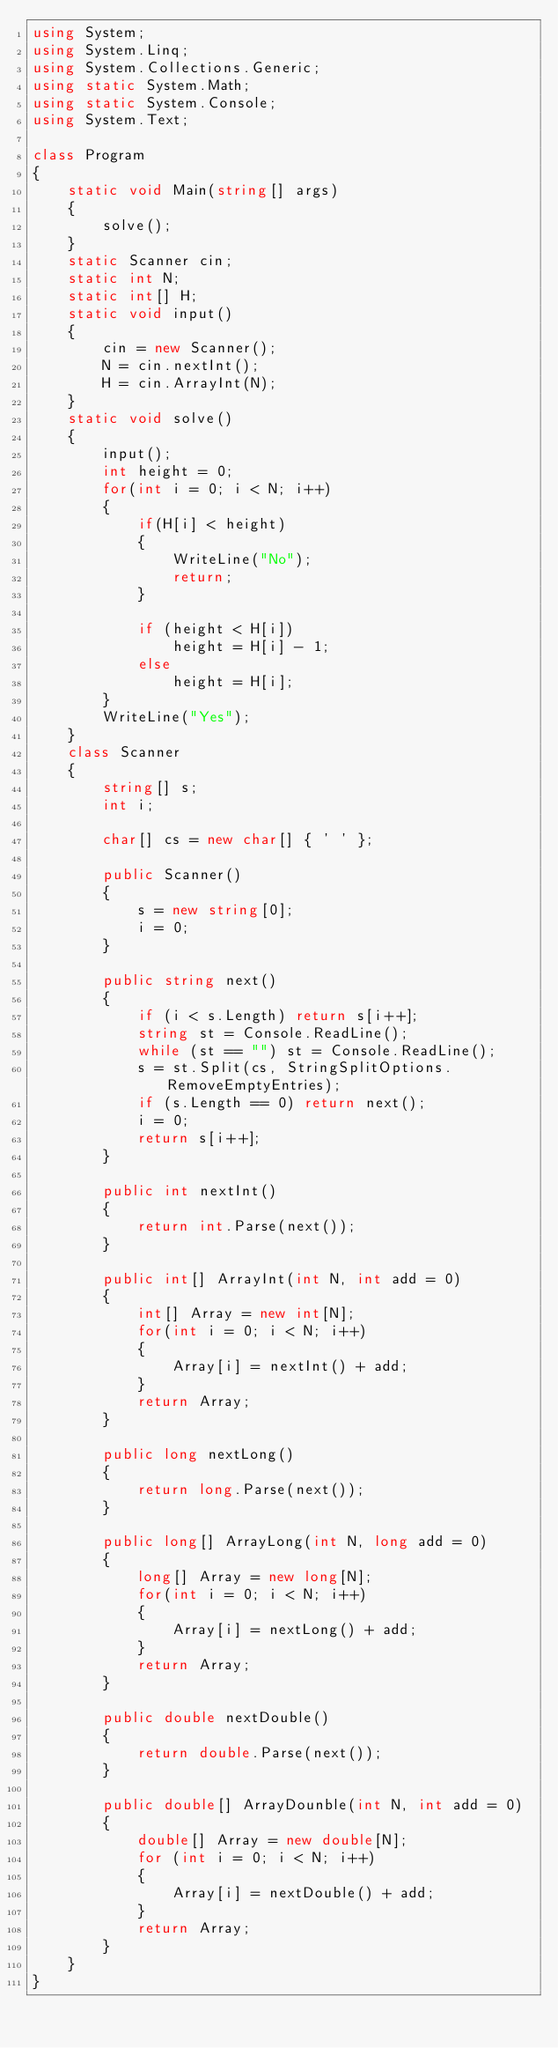<code> <loc_0><loc_0><loc_500><loc_500><_C#_>using System;
using System.Linq;
using System.Collections.Generic;
using static System.Math;
using static System.Console;
using System.Text;

class Program
{
    static void Main(string[] args)
    {
        solve();
    }
    static Scanner cin;
    static int N;
    static int[] H;
    static void input()
    {
        cin = new Scanner();
        N = cin.nextInt();
        H = cin.ArrayInt(N);
    }
    static void solve()
    {
        input();
        int height = 0;
        for(int i = 0; i < N; i++)
        {
            if(H[i] < height)
            {
                WriteLine("No");
                return;
            }

            if (height < H[i])
                height = H[i] - 1;
            else
                height = H[i];
        }
        WriteLine("Yes");
    }
    class Scanner
    {
        string[] s;
        int i;

        char[] cs = new char[] { ' ' };

        public Scanner()
        {
            s = new string[0];
            i = 0;
        }
        
        public string next()
        {
            if (i < s.Length) return s[i++];
            string st = Console.ReadLine();
            while (st == "") st = Console.ReadLine();
            s = st.Split(cs, StringSplitOptions.RemoveEmptyEntries);
            if (s.Length == 0) return next();
            i = 0;
            return s[i++];
        }

        public int nextInt()
        {
            return int.Parse(next());
        }

        public int[] ArrayInt(int N, int add = 0)
        {
            int[] Array = new int[N];
            for(int i = 0; i < N; i++)
            {
                Array[i] = nextInt() + add;
            }
            return Array;
        }

        public long nextLong()
        {
            return long.Parse(next());
        }

        public long[] ArrayLong(int N, long add = 0)
        {
            long[] Array = new long[N];
            for(int i = 0; i < N; i++)
            {
                Array[i] = nextLong() + add;
            }
            return Array;
        }

        public double nextDouble()
        {
            return double.Parse(next());
        }

        public double[] ArrayDounble(int N, int add = 0)
        {
            double[] Array = new double[N];
            for (int i = 0; i < N; i++)
            {
                Array[i] = nextDouble() + add;
            }
            return Array;
        }
    }
}</code> 